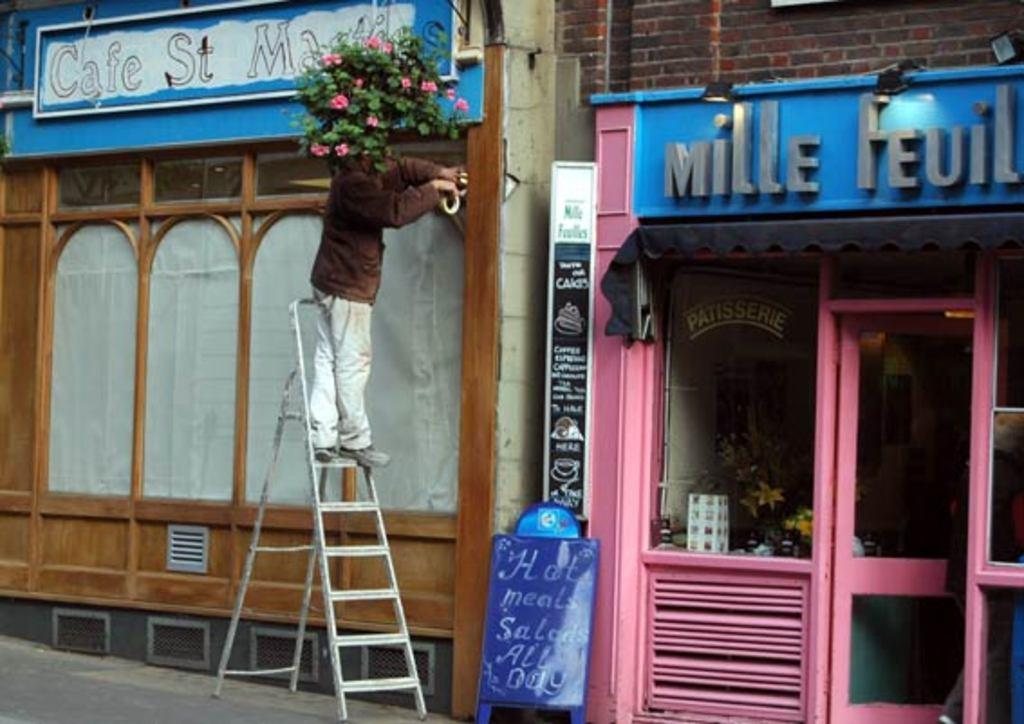<image>
Provide a brief description of the given image. A restaurant signboard declaring that Hot meals and salads served all day. 